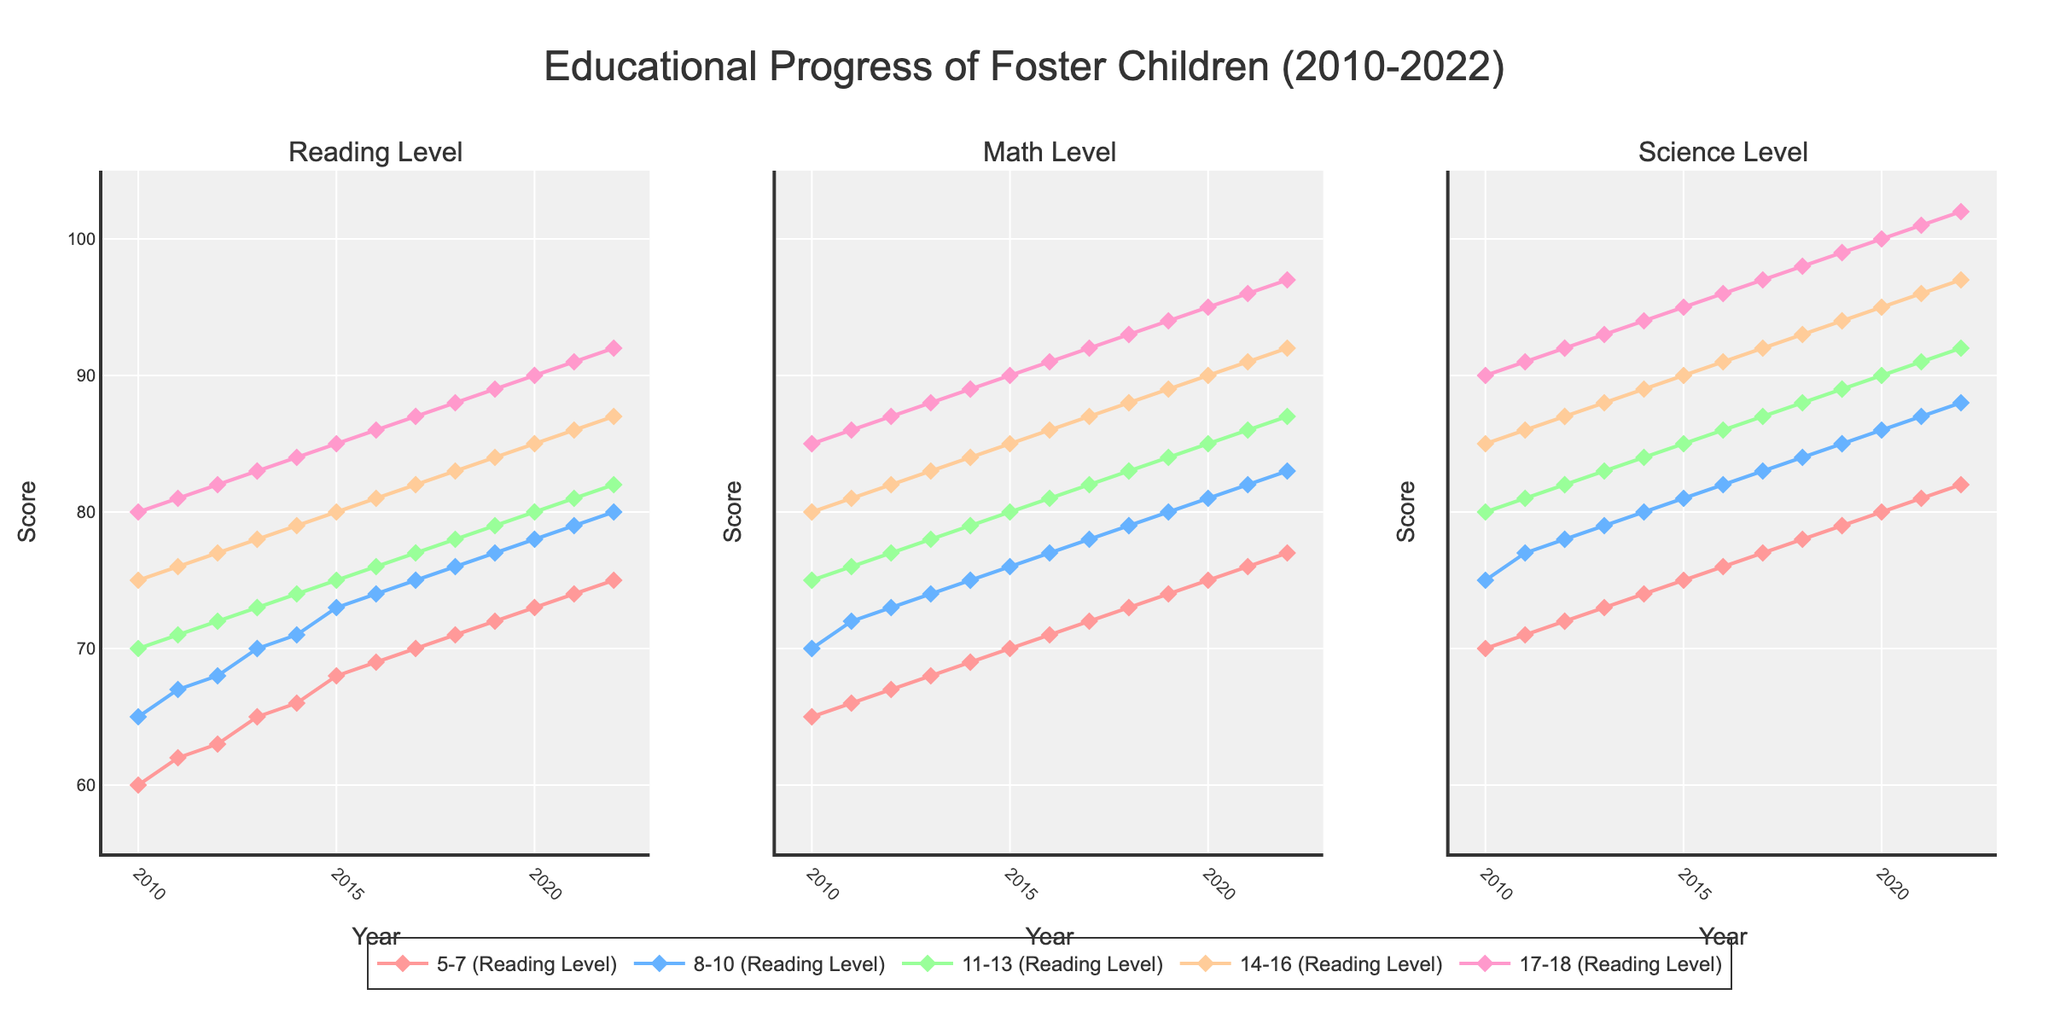What is the title of the figure? The title is usually located at the top of the figure. In this case, it should state the subject of the figure, which is provided in the code snippet.
Answer: Educational Progress of Foster Children (2010-2022) Which age group had the highest Math level in 2020? Locate the year 2020 on the x-axis, then refer to the Math Level subplot. Identify the highest point and refer to the corresponding age group in the legend.
Answer: 17-18 By how much did the Reading Level for the age group 5-7 increase from 2010 to 2022? Refer to the subplot titled 'Reading Level.' Find the data points for the age group 5-7 in 2010 and 2022 and subtract the 2010 value from the 2022 value.
Answer: 15 Which subject had the most significant improvement for the age group 14-16 over the entire period? Compare the slopes of the lines in the different subplots for the age group 14-16. The line with the steepest slope indicates the most significant improvement.
Answer: Science Level What are the color indicators used for different age groups? The code mentions colors but doesn't specify them beyond hex codes. However, visually you can match the colors in the plot legend to the distinct age groups.
Answer: Shades of red, blue, green, orange, and pink Which year shows the smoothest (least change) trend in Scores across all age groups? Analyze year-to-year trends across all three plots. The year with the most overlapping lines (less steep slopes) and fewer abrupt changes indicate the smoothest trend.
Answer: 2011 How do the scores of the 17-18 age group compare across the three subjects in 2022? Refer to the year 2022 on the x-axis for all three subplots and compare the y-values for the 17-18 age group.
Answer: Reading: 92, Math: 97, Science: 102 What is the minimum Reading Level for the age group 8-10 across all years? Refer to the subplot titled 'Reading Level' and identify the lowest point on the line for the age group 8-10 across all years.
Answer: 65 Which age group shows the most consistent performance in Science Levels from 2010 to 2022? Analyze the Science Level subplot for the smoothest, least varying trend line across the years for each age group.
Answer: 11-13 In which year did the 14-16 age group surpass an 80 on the Math Level for the first time? Refer to the Math Level subplot, track the age group 14-16, and find the first year where their score exceeds 80.
Answer: 2012 